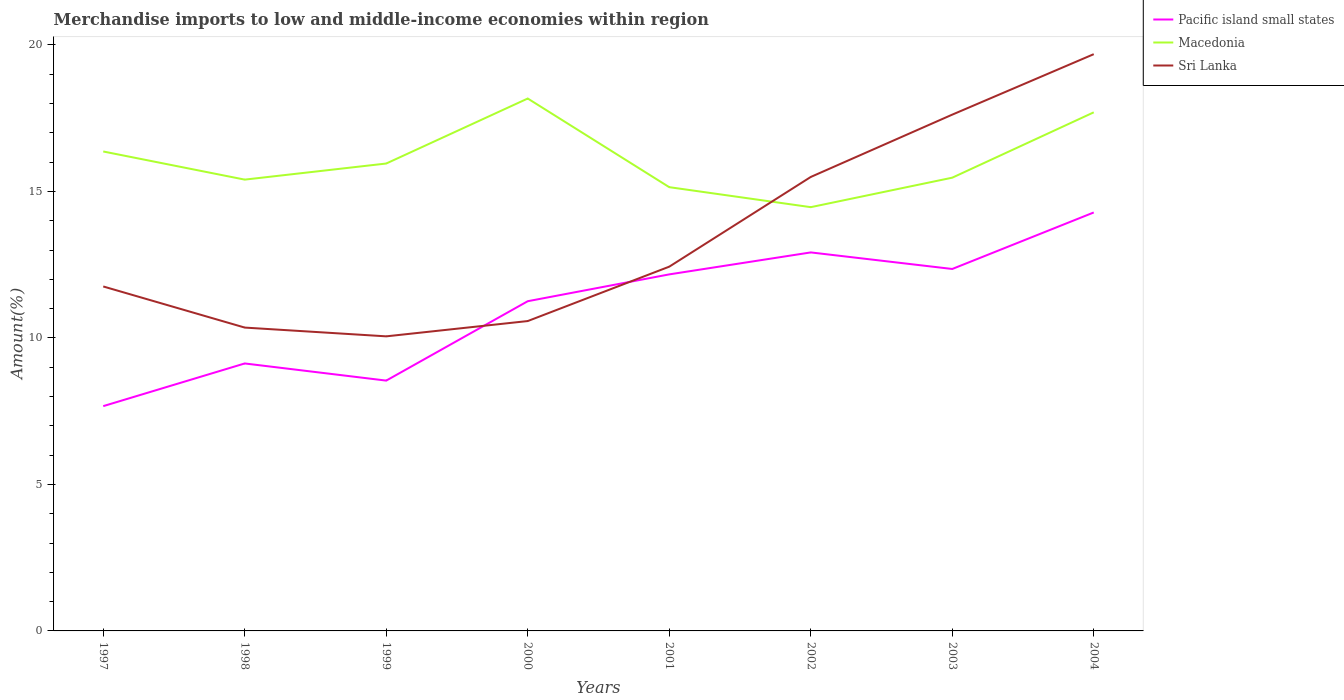How many different coloured lines are there?
Offer a terse response. 3. Does the line corresponding to Sri Lanka intersect with the line corresponding to Macedonia?
Ensure brevity in your answer.  Yes. Is the number of lines equal to the number of legend labels?
Ensure brevity in your answer.  Yes. Across all years, what is the maximum percentage of amount earned from merchandise imports in Sri Lanka?
Offer a terse response. 10.05. In which year was the percentage of amount earned from merchandise imports in Macedonia maximum?
Offer a very short reply. 2002. What is the total percentage of amount earned from merchandise imports in Sri Lanka in the graph?
Ensure brevity in your answer.  -0.22. What is the difference between the highest and the second highest percentage of amount earned from merchandise imports in Macedonia?
Your response must be concise. 3.71. Is the percentage of amount earned from merchandise imports in Pacific island small states strictly greater than the percentage of amount earned from merchandise imports in Macedonia over the years?
Provide a succinct answer. Yes. Are the values on the major ticks of Y-axis written in scientific E-notation?
Make the answer very short. No. Does the graph contain any zero values?
Make the answer very short. No. Where does the legend appear in the graph?
Your answer should be compact. Top right. How many legend labels are there?
Offer a very short reply. 3. What is the title of the graph?
Your answer should be compact. Merchandise imports to low and middle-income economies within region. Does "St. Martin (French part)" appear as one of the legend labels in the graph?
Give a very brief answer. No. What is the label or title of the Y-axis?
Your answer should be very brief. Amount(%). What is the Amount(%) of Pacific island small states in 1997?
Keep it short and to the point. 7.67. What is the Amount(%) of Macedonia in 1997?
Your answer should be compact. 16.36. What is the Amount(%) in Sri Lanka in 1997?
Your answer should be compact. 11.76. What is the Amount(%) of Pacific island small states in 1998?
Offer a very short reply. 9.13. What is the Amount(%) of Macedonia in 1998?
Offer a terse response. 15.4. What is the Amount(%) in Sri Lanka in 1998?
Your answer should be compact. 10.35. What is the Amount(%) of Pacific island small states in 1999?
Provide a succinct answer. 8.54. What is the Amount(%) in Macedonia in 1999?
Provide a short and direct response. 15.95. What is the Amount(%) in Sri Lanka in 1999?
Offer a terse response. 10.05. What is the Amount(%) in Pacific island small states in 2000?
Offer a terse response. 11.25. What is the Amount(%) of Macedonia in 2000?
Your answer should be compact. 18.17. What is the Amount(%) of Sri Lanka in 2000?
Provide a succinct answer. 10.58. What is the Amount(%) in Pacific island small states in 2001?
Give a very brief answer. 12.17. What is the Amount(%) in Macedonia in 2001?
Your response must be concise. 15.15. What is the Amount(%) in Sri Lanka in 2001?
Provide a succinct answer. 12.43. What is the Amount(%) in Pacific island small states in 2002?
Give a very brief answer. 12.92. What is the Amount(%) of Macedonia in 2002?
Keep it short and to the point. 14.46. What is the Amount(%) of Sri Lanka in 2002?
Provide a succinct answer. 15.49. What is the Amount(%) in Pacific island small states in 2003?
Your answer should be very brief. 12.35. What is the Amount(%) in Macedonia in 2003?
Make the answer very short. 15.47. What is the Amount(%) of Sri Lanka in 2003?
Ensure brevity in your answer.  17.62. What is the Amount(%) in Pacific island small states in 2004?
Keep it short and to the point. 14.28. What is the Amount(%) of Macedonia in 2004?
Offer a very short reply. 17.7. What is the Amount(%) in Sri Lanka in 2004?
Your answer should be very brief. 19.69. Across all years, what is the maximum Amount(%) of Pacific island small states?
Your answer should be very brief. 14.28. Across all years, what is the maximum Amount(%) of Macedonia?
Offer a very short reply. 18.17. Across all years, what is the maximum Amount(%) in Sri Lanka?
Your answer should be compact. 19.69. Across all years, what is the minimum Amount(%) in Pacific island small states?
Offer a very short reply. 7.67. Across all years, what is the minimum Amount(%) in Macedonia?
Your answer should be compact. 14.46. Across all years, what is the minimum Amount(%) of Sri Lanka?
Keep it short and to the point. 10.05. What is the total Amount(%) in Pacific island small states in the graph?
Ensure brevity in your answer.  88.32. What is the total Amount(%) in Macedonia in the graph?
Make the answer very short. 128.67. What is the total Amount(%) in Sri Lanka in the graph?
Provide a short and direct response. 107.98. What is the difference between the Amount(%) of Pacific island small states in 1997 and that in 1998?
Your response must be concise. -1.46. What is the difference between the Amount(%) in Macedonia in 1997 and that in 1998?
Provide a short and direct response. 0.96. What is the difference between the Amount(%) of Sri Lanka in 1997 and that in 1998?
Keep it short and to the point. 1.4. What is the difference between the Amount(%) in Pacific island small states in 1997 and that in 1999?
Ensure brevity in your answer.  -0.87. What is the difference between the Amount(%) of Macedonia in 1997 and that in 1999?
Keep it short and to the point. 0.41. What is the difference between the Amount(%) in Sri Lanka in 1997 and that in 1999?
Your answer should be compact. 1.7. What is the difference between the Amount(%) of Pacific island small states in 1997 and that in 2000?
Give a very brief answer. -3.58. What is the difference between the Amount(%) of Macedonia in 1997 and that in 2000?
Provide a short and direct response. -1.81. What is the difference between the Amount(%) of Sri Lanka in 1997 and that in 2000?
Provide a short and direct response. 1.18. What is the difference between the Amount(%) in Pacific island small states in 1997 and that in 2001?
Your answer should be compact. -4.5. What is the difference between the Amount(%) of Macedonia in 1997 and that in 2001?
Your response must be concise. 1.22. What is the difference between the Amount(%) in Sri Lanka in 1997 and that in 2001?
Offer a terse response. -0.68. What is the difference between the Amount(%) in Pacific island small states in 1997 and that in 2002?
Your response must be concise. -5.25. What is the difference between the Amount(%) of Macedonia in 1997 and that in 2002?
Your answer should be compact. 1.9. What is the difference between the Amount(%) in Sri Lanka in 1997 and that in 2002?
Your answer should be compact. -3.74. What is the difference between the Amount(%) of Pacific island small states in 1997 and that in 2003?
Keep it short and to the point. -4.68. What is the difference between the Amount(%) of Macedonia in 1997 and that in 2003?
Offer a very short reply. 0.89. What is the difference between the Amount(%) of Sri Lanka in 1997 and that in 2003?
Your response must be concise. -5.86. What is the difference between the Amount(%) in Pacific island small states in 1997 and that in 2004?
Give a very brief answer. -6.61. What is the difference between the Amount(%) in Macedonia in 1997 and that in 2004?
Keep it short and to the point. -1.34. What is the difference between the Amount(%) in Sri Lanka in 1997 and that in 2004?
Keep it short and to the point. -7.93. What is the difference between the Amount(%) of Pacific island small states in 1998 and that in 1999?
Provide a succinct answer. 0.59. What is the difference between the Amount(%) in Macedonia in 1998 and that in 1999?
Keep it short and to the point. -0.55. What is the difference between the Amount(%) of Sri Lanka in 1998 and that in 1999?
Provide a succinct answer. 0.3. What is the difference between the Amount(%) in Pacific island small states in 1998 and that in 2000?
Your response must be concise. -2.12. What is the difference between the Amount(%) of Macedonia in 1998 and that in 2000?
Keep it short and to the point. -2.77. What is the difference between the Amount(%) of Sri Lanka in 1998 and that in 2000?
Provide a succinct answer. -0.22. What is the difference between the Amount(%) in Pacific island small states in 1998 and that in 2001?
Provide a succinct answer. -3.04. What is the difference between the Amount(%) of Macedonia in 1998 and that in 2001?
Offer a terse response. 0.26. What is the difference between the Amount(%) in Sri Lanka in 1998 and that in 2001?
Your answer should be very brief. -2.08. What is the difference between the Amount(%) of Pacific island small states in 1998 and that in 2002?
Make the answer very short. -3.79. What is the difference between the Amount(%) in Macedonia in 1998 and that in 2002?
Make the answer very short. 0.94. What is the difference between the Amount(%) in Sri Lanka in 1998 and that in 2002?
Your response must be concise. -5.14. What is the difference between the Amount(%) in Pacific island small states in 1998 and that in 2003?
Give a very brief answer. -3.23. What is the difference between the Amount(%) in Macedonia in 1998 and that in 2003?
Make the answer very short. -0.07. What is the difference between the Amount(%) in Sri Lanka in 1998 and that in 2003?
Offer a terse response. -7.27. What is the difference between the Amount(%) in Pacific island small states in 1998 and that in 2004?
Make the answer very short. -5.15. What is the difference between the Amount(%) of Macedonia in 1998 and that in 2004?
Ensure brevity in your answer.  -2.3. What is the difference between the Amount(%) of Sri Lanka in 1998 and that in 2004?
Ensure brevity in your answer.  -9.33. What is the difference between the Amount(%) of Pacific island small states in 1999 and that in 2000?
Your answer should be compact. -2.71. What is the difference between the Amount(%) in Macedonia in 1999 and that in 2000?
Provide a succinct answer. -2.22. What is the difference between the Amount(%) in Sri Lanka in 1999 and that in 2000?
Your response must be concise. -0.52. What is the difference between the Amount(%) in Pacific island small states in 1999 and that in 2001?
Your answer should be compact. -3.63. What is the difference between the Amount(%) of Macedonia in 1999 and that in 2001?
Ensure brevity in your answer.  0.81. What is the difference between the Amount(%) of Sri Lanka in 1999 and that in 2001?
Keep it short and to the point. -2.38. What is the difference between the Amount(%) of Pacific island small states in 1999 and that in 2002?
Your response must be concise. -4.38. What is the difference between the Amount(%) in Macedonia in 1999 and that in 2002?
Your response must be concise. 1.49. What is the difference between the Amount(%) in Sri Lanka in 1999 and that in 2002?
Ensure brevity in your answer.  -5.44. What is the difference between the Amount(%) of Pacific island small states in 1999 and that in 2003?
Your answer should be very brief. -3.81. What is the difference between the Amount(%) in Macedonia in 1999 and that in 2003?
Ensure brevity in your answer.  0.48. What is the difference between the Amount(%) in Sri Lanka in 1999 and that in 2003?
Your answer should be compact. -7.57. What is the difference between the Amount(%) of Pacific island small states in 1999 and that in 2004?
Give a very brief answer. -5.74. What is the difference between the Amount(%) in Macedonia in 1999 and that in 2004?
Make the answer very short. -1.75. What is the difference between the Amount(%) in Sri Lanka in 1999 and that in 2004?
Keep it short and to the point. -9.63. What is the difference between the Amount(%) of Pacific island small states in 2000 and that in 2001?
Your response must be concise. -0.92. What is the difference between the Amount(%) in Macedonia in 2000 and that in 2001?
Offer a terse response. 3.03. What is the difference between the Amount(%) of Sri Lanka in 2000 and that in 2001?
Offer a very short reply. -1.86. What is the difference between the Amount(%) of Pacific island small states in 2000 and that in 2002?
Offer a very short reply. -1.67. What is the difference between the Amount(%) of Macedonia in 2000 and that in 2002?
Offer a terse response. 3.71. What is the difference between the Amount(%) of Sri Lanka in 2000 and that in 2002?
Give a very brief answer. -4.92. What is the difference between the Amount(%) of Pacific island small states in 2000 and that in 2003?
Offer a terse response. -1.1. What is the difference between the Amount(%) of Macedonia in 2000 and that in 2003?
Your answer should be compact. 2.7. What is the difference between the Amount(%) in Sri Lanka in 2000 and that in 2003?
Give a very brief answer. -7.05. What is the difference between the Amount(%) in Pacific island small states in 2000 and that in 2004?
Your response must be concise. -3.03. What is the difference between the Amount(%) of Macedonia in 2000 and that in 2004?
Your answer should be compact. 0.47. What is the difference between the Amount(%) in Sri Lanka in 2000 and that in 2004?
Keep it short and to the point. -9.11. What is the difference between the Amount(%) in Pacific island small states in 2001 and that in 2002?
Provide a short and direct response. -0.75. What is the difference between the Amount(%) of Macedonia in 2001 and that in 2002?
Offer a very short reply. 0.68. What is the difference between the Amount(%) of Sri Lanka in 2001 and that in 2002?
Your answer should be compact. -3.06. What is the difference between the Amount(%) in Pacific island small states in 2001 and that in 2003?
Give a very brief answer. -0.18. What is the difference between the Amount(%) of Macedonia in 2001 and that in 2003?
Keep it short and to the point. -0.32. What is the difference between the Amount(%) of Sri Lanka in 2001 and that in 2003?
Your response must be concise. -5.19. What is the difference between the Amount(%) in Pacific island small states in 2001 and that in 2004?
Your answer should be compact. -2.11. What is the difference between the Amount(%) in Macedonia in 2001 and that in 2004?
Your response must be concise. -2.55. What is the difference between the Amount(%) of Sri Lanka in 2001 and that in 2004?
Your response must be concise. -7.25. What is the difference between the Amount(%) of Pacific island small states in 2002 and that in 2003?
Your answer should be compact. 0.56. What is the difference between the Amount(%) in Macedonia in 2002 and that in 2003?
Your response must be concise. -1.01. What is the difference between the Amount(%) in Sri Lanka in 2002 and that in 2003?
Keep it short and to the point. -2.13. What is the difference between the Amount(%) in Pacific island small states in 2002 and that in 2004?
Provide a short and direct response. -1.36. What is the difference between the Amount(%) in Macedonia in 2002 and that in 2004?
Offer a terse response. -3.24. What is the difference between the Amount(%) of Sri Lanka in 2002 and that in 2004?
Provide a succinct answer. -4.19. What is the difference between the Amount(%) in Pacific island small states in 2003 and that in 2004?
Ensure brevity in your answer.  -1.93. What is the difference between the Amount(%) of Macedonia in 2003 and that in 2004?
Offer a terse response. -2.23. What is the difference between the Amount(%) in Sri Lanka in 2003 and that in 2004?
Your answer should be compact. -2.06. What is the difference between the Amount(%) of Pacific island small states in 1997 and the Amount(%) of Macedonia in 1998?
Offer a very short reply. -7.73. What is the difference between the Amount(%) in Pacific island small states in 1997 and the Amount(%) in Sri Lanka in 1998?
Offer a terse response. -2.68. What is the difference between the Amount(%) in Macedonia in 1997 and the Amount(%) in Sri Lanka in 1998?
Provide a succinct answer. 6.01. What is the difference between the Amount(%) of Pacific island small states in 1997 and the Amount(%) of Macedonia in 1999?
Give a very brief answer. -8.28. What is the difference between the Amount(%) of Pacific island small states in 1997 and the Amount(%) of Sri Lanka in 1999?
Provide a short and direct response. -2.38. What is the difference between the Amount(%) in Macedonia in 1997 and the Amount(%) in Sri Lanka in 1999?
Keep it short and to the point. 6.31. What is the difference between the Amount(%) in Pacific island small states in 1997 and the Amount(%) in Macedonia in 2000?
Offer a terse response. -10.5. What is the difference between the Amount(%) of Pacific island small states in 1997 and the Amount(%) of Sri Lanka in 2000?
Ensure brevity in your answer.  -2.9. What is the difference between the Amount(%) of Macedonia in 1997 and the Amount(%) of Sri Lanka in 2000?
Give a very brief answer. 5.79. What is the difference between the Amount(%) of Pacific island small states in 1997 and the Amount(%) of Macedonia in 2001?
Ensure brevity in your answer.  -7.47. What is the difference between the Amount(%) in Pacific island small states in 1997 and the Amount(%) in Sri Lanka in 2001?
Ensure brevity in your answer.  -4.76. What is the difference between the Amount(%) in Macedonia in 1997 and the Amount(%) in Sri Lanka in 2001?
Provide a succinct answer. 3.93. What is the difference between the Amount(%) of Pacific island small states in 1997 and the Amount(%) of Macedonia in 2002?
Your answer should be compact. -6.79. What is the difference between the Amount(%) of Pacific island small states in 1997 and the Amount(%) of Sri Lanka in 2002?
Your answer should be compact. -7.82. What is the difference between the Amount(%) in Macedonia in 1997 and the Amount(%) in Sri Lanka in 2002?
Your response must be concise. 0.87. What is the difference between the Amount(%) in Pacific island small states in 1997 and the Amount(%) in Macedonia in 2003?
Your answer should be very brief. -7.8. What is the difference between the Amount(%) of Pacific island small states in 1997 and the Amount(%) of Sri Lanka in 2003?
Offer a terse response. -9.95. What is the difference between the Amount(%) in Macedonia in 1997 and the Amount(%) in Sri Lanka in 2003?
Ensure brevity in your answer.  -1.26. What is the difference between the Amount(%) of Pacific island small states in 1997 and the Amount(%) of Macedonia in 2004?
Your response must be concise. -10.03. What is the difference between the Amount(%) of Pacific island small states in 1997 and the Amount(%) of Sri Lanka in 2004?
Provide a succinct answer. -12.01. What is the difference between the Amount(%) of Macedonia in 1997 and the Amount(%) of Sri Lanka in 2004?
Offer a terse response. -3.32. What is the difference between the Amount(%) of Pacific island small states in 1998 and the Amount(%) of Macedonia in 1999?
Offer a terse response. -6.82. What is the difference between the Amount(%) of Pacific island small states in 1998 and the Amount(%) of Sri Lanka in 1999?
Provide a short and direct response. -0.93. What is the difference between the Amount(%) of Macedonia in 1998 and the Amount(%) of Sri Lanka in 1999?
Your answer should be very brief. 5.35. What is the difference between the Amount(%) of Pacific island small states in 1998 and the Amount(%) of Macedonia in 2000?
Your response must be concise. -9.04. What is the difference between the Amount(%) of Pacific island small states in 1998 and the Amount(%) of Sri Lanka in 2000?
Keep it short and to the point. -1.45. What is the difference between the Amount(%) of Macedonia in 1998 and the Amount(%) of Sri Lanka in 2000?
Your response must be concise. 4.83. What is the difference between the Amount(%) in Pacific island small states in 1998 and the Amount(%) in Macedonia in 2001?
Offer a very short reply. -6.02. What is the difference between the Amount(%) in Pacific island small states in 1998 and the Amount(%) in Sri Lanka in 2001?
Your answer should be compact. -3.3. What is the difference between the Amount(%) in Macedonia in 1998 and the Amount(%) in Sri Lanka in 2001?
Provide a short and direct response. 2.97. What is the difference between the Amount(%) in Pacific island small states in 1998 and the Amount(%) in Macedonia in 2002?
Keep it short and to the point. -5.33. What is the difference between the Amount(%) of Pacific island small states in 1998 and the Amount(%) of Sri Lanka in 2002?
Provide a succinct answer. -6.37. What is the difference between the Amount(%) of Macedonia in 1998 and the Amount(%) of Sri Lanka in 2002?
Give a very brief answer. -0.09. What is the difference between the Amount(%) in Pacific island small states in 1998 and the Amount(%) in Macedonia in 2003?
Keep it short and to the point. -6.34. What is the difference between the Amount(%) of Pacific island small states in 1998 and the Amount(%) of Sri Lanka in 2003?
Give a very brief answer. -8.49. What is the difference between the Amount(%) of Macedonia in 1998 and the Amount(%) of Sri Lanka in 2003?
Your answer should be very brief. -2.22. What is the difference between the Amount(%) in Pacific island small states in 1998 and the Amount(%) in Macedonia in 2004?
Offer a terse response. -8.57. What is the difference between the Amount(%) in Pacific island small states in 1998 and the Amount(%) in Sri Lanka in 2004?
Ensure brevity in your answer.  -10.56. What is the difference between the Amount(%) of Macedonia in 1998 and the Amount(%) of Sri Lanka in 2004?
Your answer should be compact. -4.28. What is the difference between the Amount(%) of Pacific island small states in 1999 and the Amount(%) of Macedonia in 2000?
Your response must be concise. -9.63. What is the difference between the Amount(%) of Pacific island small states in 1999 and the Amount(%) of Sri Lanka in 2000?
Give a very brief answer. -2.03. What is the difference between the Amount(%) in Macedonia in 1999 and the Amount(%) in Sri Lanka in 2000?
Give a very brief answer. 5.38. What is the difference between the Amount(%) in Pacific island small states in 1999 and the Amount(%) in Macedonia in 2001?
Keep it short and to the point. -6.6. What is the difference between the Amount(%) of Pacific island small states in 1999 and the Amount(%) of Sri Lanka in 2001?
Your response must be concise. -3.89. What is the difference between the Amount(%) of Macedonia in 1999 and the Amount(%) of Sri Lanka in 2001?
Your answer should be compact. 3.52. What is the difference between the Amount(%) in Pacific island small states in 1999 and the Amount(%) in Macedonia in 2002?
Offer a terse response. -5.92. What is the difference between the Amount(%) in Pacific island small states in 1999 and the Amount(%) in Sri Lanka in 2002?
Give a very brief answer. -6.95. What is the difference between the Amount(%) in Macedonia in 1999 and the Amount(%) in Sri Lanka in 2002?
Give a very brief answer. 0.46. What is the difference between the Amount(%) of Pacific island small states in 1999 and the Amount(%) of Macedonia in 2003?
Give a very brief answer. -6.93. What is the difference between the Amount(%) of Pacific island small states in 1999 and the Amount(%) of Sri Lanka in 2003?
Offer a very short reply. -9.08. What is the difference between the Amount(%) in Macedonia in 1999 and the Amount(%) in Sri Lanka in 2003?
Your response must be concise. -1.67. What is the difference between the Amount(%) in Pacific island small states in 1999 and the Amount(%) in Macedonia in 2004?
Offer a very short reply. -9.16. What is the difference between the Amount(%) of Pacific island small states in 1999 and the Amount(%) of Sri Lanka in 2004?
Make the answer very short. -11.14. What is the difference between the Amount(%) in Macedonia in 1999 and the Amount(%) in Sri Lanka in 2004?
Keep it short and to the point. -3.73. What is the difference between the Amount(%) in Pacific island small states in 2000 and the Amount(%) in Macedonia in 2001?
Offer a terse response. -3.89. What is the difference between the Amount(%) in Pacific island small states in 2000 and the Amount(%) in Sri Lanka in 2001?
Ensure brevity in your answer.  -1.18. What is the difference between the Amount(%) of Macedonia in 2000 and the Amount(%) of Sri Lanka in 2001?
Keep it short and to the point. 5.74. What is the difference between the Amount(%) in Pacific island small states in 2000 and the Amount(%) in Macedonia in 2002?
Your answer should be very brief. -3.21. What is the difference between the Amount(%) of Pacific island small states in 2000 and the Amount(%) of Sri Lanka in 2002?
Offer a very short reply. -4.24. What is the difference between the Amount(%) in Macedonia in 2000 and the Amount(%) in Sri Lanka in 2002?
Offer a very short reply. 2.68. What is the difference between the Amount(%) of Pacific island small states in 2000 and the Amount(%) of Macedonia in 2003?
Make the answer very short. -4.22. What is the difference between the Amount(%) of Pacific island small states in 2000 and the Amount(%) of Sri Lanka in 2003?
Your answer should be compact. -6.37. What is the difference between the Amount(%) of Macedonia in 2000 and the Amount(%) of Sri Lanka in 2003?
Provide a short and direct response. 0.55. What is the difference between the Amount(%) of Pacific island small states in 2000 and the Amount(%) of Macedonia in 2004?
Keep it short and to the point. -6.45. What is the difference between the Amount(%) in Pacific island small states in 2000 and the Amount(%) in Sri Lanka in 2004?
Make the answer very short. -8.43. What is the difference between the Amount(%) in Macedonia in 2000 and the Amount(%) in Sri Lanka in 2004?
Ensure brevity in your answer.  -1.51. What is the difference between the Amount(%) of Pacific island small states in 2001 and the Amount(%) of Macedonia in 2002?
Make the answer very short. -2.29. What is the difference between the Amount(%) in Pacific island small states in 2001 and the Amount(%) in Sri Lanka in 2002?
Ensure brevity in your answer.  -3.33. What is the difference between the Amount(%) of Macedonia in 2001 and the Amount(%) of Sri Lanka in 2002?
Your answer should be very brief. -0.35. What is the difference between the Amount(%) in Pacific island small states in 2001 and the Amount(%) in Macedonia in 2003?
Ensure brevity in your answer.  -3.3. What is the difference between the Amount(%) of Pacific island small states in 2001 and the Amount(%) of Sri Lanka in 2003?
Keep it short and to the point. -5.45. What is the difference between the Amount(%) in Macedonia in 2001 and the Amount(%) in Sri Lanka in 2003?
Offer a terse response. -2.48. What is the difference between the Amount(%) in Pacific island small states in 2001 and the Amount(%) in Macedonia in 2004?
Your response must be concise. -5.53. What is the difference between the Amount(%) in Pacific island small states in 2001 and the Amount(%) in Sri Lanka in 2004?
Offer a very short reply. -7.52. What is the difference between the Amount(%) of Macedonia in 2001 and the Amount(%) of Sri Lanka in 2004?
Provide a succinct answer. -4.54. What is the difference between the Amount(%) in Pacific island small states in 2002 and the Amount(%) in Macedonia in 2003?
Give a very brief answer. -2.55. What is the difference between the Amount(%) of Pacific island small states in 2002 and the Amount(%) of Sri Lanka in 2003?
Provide a succinct answer. -4.7. What is the difference between the Amount(%) in Macedonia in 2002 and the Amount(%) in Sri Lanka in 2003?
Provide a succinct answer. -3.16. What is the difference between the Amount(%) of Pacific island small states in 2002 and the Amount(%) of Macedonia in 2004?
Provide a short and direct response. -4.78. What is the difference between the Amount(%) in Pacific island small states in 2002 and the Amount(%) in Sri Lanka in 2004?
Ensure brevity in your answer.  -6.77. What is the difference between the Amount(%) of Macedonia in 2002 and the Amount(%) of Sri Lanka in 2004?
Your response must be concise. -5.22. What is the difference between the Amount(%) of Pacific island small states in 2003 and the Amount(%) of Macedonia in 2004?
Provide a succinct answer. -5.35. What is the difference between the Amount(%) in Pacific island small states in 2003 and the Amount(%) in Sri Lanka in 2004?
Your answer should be compact. -7.33. What is the difference between the Amount(%) in Macedonia in 2003 and the Amount(%) in Sri Lanka in 2004?
Your response must be concise. -4.22. What is the average Amount(%) in Pacific island small states per year?
Offer a terse response. 11.04. What is the average Amount(%) in Macedonia per year?
Make the answer very short. 16.08. What is the average Amount(%) of Sri Lanka per year?
Ensure brevity in your answer.  13.5. In the year 1997, what is the difference between the Amount(%) in Pacific island small states and Amount(%) in Macedonia?
Your answer should be very brief. -8.69. In the year 1997, what is the difference between the Amount(%) in Pacific island small states and Amount(%) in Sri Lanka?
Ensure brevity in your answer.  -4.08. In the year 1997, what is the difference between the Amount(%) of Macedonia and Amount(%) of Sri Lanka?
Your response must be concise. 4.61. In the year 1998, what is the difference between the Amount(%) in Pacific island small states and Amount(%) in Macedonia?
Keep it short and to the point. -6.27. In the year 1998, what is the difference between the Amount(%) in Pacific island small states and Amount(%) in Sri Lanka?
Provide a succinct answer. -1.22. In the year 1998, what is the difference between the Amount(%) in Macedonia and Amount(%) in Sri Lanka?
Keep it short and to the point. 5.05. In the year 1999, what is the difference between the Amount(%) in Pacific island small states and Amount(%) in Macedonia?
Provide a short and direct response. -7.41. In the year 1999, what is the difference between the Amount(%) in Pacific island small states and Amount(%) in Sri Lanka?
Offer a terse response. -1.51. In the year 1999, what is the difference between the Amount(%) in Macedonia and Amount(%) in Sri Lanka?
Your answer should be very brief. 5.9. In the year 2000, what is the difference between the Amount(%) of Pacific island small states and Amount(%) of Macedonia?
Your answer should be very brief. -6.92. In the year 2000, what is the difference between the Amount(%) of Pacific island small states and Amount(%) of Sri Lanka?
Your answer should be compact. 0.68. In the year 2000, what is the difference between the Amount(%) of Macedonia and Amount(%) of Sri Lanka?
Your response must be concise. 7.6. In the year 2001, what is the difference between the Amount(%) of Pacific island small states and Amount(%) of Macedonia?
Provide a short and direct response. -2.98. In the year 2001, what is the difference between the Amount(%) in Pacific island small states and Amount(%) in Sri Lanka?
Your answer should be very brief. -0.26. In the year 2001, what is the difference between the Amount(%) of Macedonia and Amount(%) of Sri Lanka?
Your response must be concise. 2.71. In the year 2002, what is the difference between the Amount(%) of Pacific island small states and Amount(%) of Macedonia?
Your answer should be very brief. -1.54. In the year 2002, what is the difference between the Amount(%) in Pacific island small states and Amount(%) in Sri Lanka?
Provide a succinct answer. -2.58. In the year 2002, what is the difference between the Amount(%) in Macedonia and Amount(%) in Sri Lanka?
Keep it short and to the point. -1.03. In the year 2003, what is the difference between the Amount(%) in Pacific island small states and Amount(%) in Macedonia?
Offer a terse response. -3.12. In the year 2003, what is the difference between the Amount(%) in Pacific island small states and Amount(%) in Sri Lanka?
Make the answer very short. -5.27. In the year 2003, what is the difference between the Amount(%) of Macedonia and Amount(%) of Sri Lanka?
Offer a very short reply. -2.15. In the year 2004, what is the difference between the Amount(%) of Pacific island small states and Amount(%) of Macedonia?
Your response must be concise. -3.42. In the year 2004, what is the difference between the Amount(%) of Pacific island small states and Amount(%) of Sri Lanka?
Offer a terse response. -5.4. In the year 2004, what is the difference between the Amount(%) in Macedonia and Amount(%) in Sri Lanka?
Provide a short and direct response. -1.99. What is the ratio of the Amount(%) in Pacific island small states in 1997 to that in 1998?
Your answer should be very brief. 0.84. What is the ratio of the Amount(%) of Macedonia in 1997 to that in 1998?
Your response must be concise. 1.06. What is the ratio of the Amount(%) of Sri Lanka in 1997 to that in 1998?
Your answer should be very brief. 1.14. What is the ratio of the Amount(%) in Pacific island small states in 1997 to that in 1999?
Your answer should be very brief. 0.9. What is the ratio of the Amount(%) in Macedonia in 1997 to that in 1999?
Give a very brief answer. 1.03. What is the ratio of the Amount(%) in Sri Lanka in 1997 to that in 1999?
Your answer should be compact. 1.17. What is the ratio of the Amount(%) of Pacific island small states in 1997 to that in 2000?
Offer a terse response. 0.68. What is the ratio of the Amount(%) in Macedonia in 1997 to that in 2000?
Keep it short and to the point. 0.9. What is the ratio of the Amount(%) of Sri Lanka in 1997 to that in 2000?
Ensure brevity in your answer.  1.11. What is the ratio of the Amount(%) in Pacific island small states in 1997 to that in 2001?
Your answer should be compact. 0.63. What is the ratio of the Amount(%) of Macedonia in 1997 to that in 2001?
Your response must be concise. 1.08. What is the ratio of the Amount(%) in Sri Lanka in 1997 to that in 2001?
Provide a succinct answer. 0.95. What is the ratio of the Amount(%) of Pacific island small states in 1997 to that in 2002?
Give a very brief answer. 0.59. What is the ratio of the Amount(%) in Macedonia in 1997 to that in 2002?
Ensure brevity in your answer.  1.13. What is the ratio of the Amount(%) in Sri Lanka in 1997 to that in 2002?
Give a very brief answer. 0.76. What is the ratio of the Amount(%) of Pacific island small states in 1997 to that in 2003?
Offer a terse response. 0.62. What is the ratio of the Amount(%) in Macedonia in 1997 to that in 2003?
Your answer should be compact. 1.06. What is the ratio of the Amount(%) in Sri Lanka in 1997 to that in 2003?
Your answer should be very brief. 0.67. What is the ratio of the Amount(%) in Pacific island small states in 1997 to that in 2004?
Offer a very short reply. 0.54. What is the ratio of the Amount(%) in Macedonia in 1997 to that in 2004?
Provide a succinct answer. 0.92. What is the ratio of the Amount(%) of Sri Lanka in 1997 to that in 2004?
Ensure brevity in your answer.  0.6. What is the ratio of the Amount(%) of Pacific island small states in 1998 to that in 1999?
Ensure brevity in your answer.  1.07. What is the ratio of the Amount(%) of Macedonia in 1998 to that in 1999?
Your answer should be very brief. 0.97. What is the ratio of the Amount(%) of Sri Lanka in 1998 to that in 1999?
Your response must be concise. 1.03. What is the ratio of the Amount(%) of Pacific island small states in 1998 to that in 2000?
Provide a succinct answer. 0.81. What is the ratio of the Amount(%) of Macedonia in 1998 to that in 2000?
Your answer should be very brief. 0.85. What is the ratio of the Amount(%) in Sri Lanka in 1998 to that in 2000?
Give a very brief answer. 0.98. What is the ratio of the Amount(%) in Pacific island small states in 1998 to that in 2001?
Give a very brief answer. 0.75. What is the ratio of the Amount(%) of Macedonia in 1998 to that in 2001?
Your answer should be very brief. 1.02. What is the ratio of the Amount(%) of Sri Lanka in 1998 to that in 2001?
Your answer should be compact. 0.83. What is the ratio of the Amount(%) in Pacific island small states in 1998 to that in 2002?
Provide a succinct answer. 0.71. What is the ratio of the Amount(%) in Macedonia in 1998 to that in 2002?
Provide a succinct answer. 1.06. What is the ratio of the Amount(%) in Sri Lanka in 1998 to that in 2002?
Ensure brevity in your answer.  0.67. What is the ratio of the Amount(%) in Pacific island small states in 1998 to that in 2003?
Offer a terse response. 0.74. What is the ratio of the Amount(%) of Macedonia in 1998 to that in 2003?
Your answer should be compact. 1. What is the ratio of the Amount(%) in Sri Lanka in 1998 to that in 2003?
Your answer should be very brief. 0.59. What is the ratio of the Amount(%) in Pacific island small states in 1998 to that in 2004?
Your answer should be very brief. 0.64. What is the ratio of the Amount(%) of Macedonia in 1998 to that in 2004?
Provide a short and direct response. 0.87. What is the ratio of the Amount(%) in Sri Lanka in 1998 to that in 2004?
Ensure brevity in your answer.  0.53. What is the ratio of the Amount(%) of Pacific island small states in 1999 to that in 2000?
Give a very brief answer. 0.76. What is the ratio of the Amount(%) in Macedonia in 1999 to that in 2000?
Your answer should be very brief. 0.88. What is the ratio of the Amount(%) in Sri Lanka in 1999 to that in 2000?
Provide a succinct answer. 0.95. What is the ratio of the Amount(%) in Pacific island small states in 1999 to that in 2001?
Offer a very short reply. 0.7. What is the ratio of the Amount(%) in Macedonia in 1999 to that in 2001?
Keep it short and to the point. 1.05. What is the ratio of the Amount(%) of Sri Lanka in 1999 to that in 2001?
Your answer should be compact. 0.81. What is the ratio of the Amount(%) in Pacific island small states in 1999 to that in 2002?
Your answer should be compact. 0.66. What is the ratio of the Amount(%) of Macedonia in 1999 to that in 2002?
Provide a succinct answer. 1.1. What is the ratio of the Amount(%) in Sri Lanka in 1999 to that in 2002?
Offer a very short reply. 0.65. What is the ratio of the Amount(%) of Pacific island small states in 1999 to that in 2003?
Make the answer very short. 0.69. What is the ratio of the Amount(%) of Macedonia in 1999 to that in 2003?
Ensure brevity in your answer.  1.03. What is the ratio of the Amount(%) in Sri Lanka in 1999 to that in 2003?
Offer a terse response. 0.57. What is the ratio of the Amount(%) in Pacific island small states in 1999 to that in 2004?
Provide a short and direct response. 0.6. What is the ratio of the Amount(%) in Macedonia in 1999 to that in 2004?
Make the answer very short. 0.9. What is the ratio of the Amount(%) of Sri Lanka in 1999 to that in 2004?
Give a very brief answer. 0.51. What is the ratio of the Amount(%) in Pacific island small states in 2000 to that in 2001?
Offer a very short reply. 0.92. What is the ratio of the Amount(%) of Macedonia in 2000 to that in 2001?
Your answer should be compact. 1.2. What is the ratio of the Amount(%) of Sri Lanka in 2000 to that in 2001?
Provide a short and direct response. 0.85. What is the ratio of the Amount(%) in Pacific island small states in 2000 to that in 2002?
Your response must be concise. 0.87. What is the ratio of the Amount(%) in Macedonia in 2000 to that in 2002?
Provide a short and direct response. 1.26. What is the ratio of the Amount(%) of Sri Lanka in 2000 to that in 2002?
Provide a succinct answer. 0.68. What is the ratio of the Amount(%) of Pacific island small states in 2000 to that in 2003?
Keep it short and to the point. 0.91. What is the ratio of the Amount(%) of Macedonia in 2000 to that in 2003?
Your answer should be compact. 1.17. What is the ratio of the Amount(%) of Sri Lanka in 2000 to that in 2003?
Ensure brevity in your answer.  0.6. What is the ratio of the Amount(%) in Pacific island small states in 2000 to that in 2004?
Ensure brevity in your answer.  0.79. What is the ratio of the Amount(%) in Macedonia in 2000 to that in 2004?
Provide a succinct answer. 1.03. What is the ratio of the Amount(%) of Sri Lanka in 2000 to that in 2004?
Ensure brevity in your answer.  0.54. What is the ratio of the Amount(%) of Pacific island small states in 2001 to that in 2002?
Make the answer very short. 0.94. What is the ratio of the Amount(%) of Macedonia in 2001 to that in 2002?
Make the answer very short. 1.05. What is the ratio of the Amount(%) in Sri Lanka in 2001 to that in 2002?
Provide a short and direct response. 0.8. What is the ratio of the Amount(%) in Pacific island small states in 2001 to that in 2003?
Keep it short and to the point. 0.99. What is the ratio of the Amount(%) of Macedonia in 2001 to that in 2003?
Offer a terse response. 0.98. What is the ratio of the Amount(%) in Sri Lanka in 2001 to that in 2003?
Give a very brief answer. 0.71. What is the ratio of the Amount(%) of Pacific island small states in 2001 to that in 2004?
Keep it short and to the point. 0.85. What is the ratio of the Amount(%) in Macedonia in 2001 to that in 2004?
Offer a very short reply. 0.86. What is the ratio of the Amount(%) of Sri Lanka in 2001 to that in 2004?
Your answer should be compact. 0.63. What is the ratio of the Amount(%) of Pacific island small states in 2002 to that in 2003?
Keep it short and to the point. 1.05. What is the ratio of the Amount(%) of Macedonia in 2002 to that in 2003?
Provide a short and direct response. 0.94. What is the ratio of the Amount(%) in Sri Lanka in 2002 to that in 2003?
Your response must be concise. 0.88. What is the ratio of the Amount(%) in Pacific island small states in 2002 to that in 2004?
Give a very brief answer. 0.9. What is the ratio of the Amount(%) of Macedonia in 2002 to that in 2004?
Offer a very short reply. 0.82. What is the ratio of the Amount(%) of Sri Lanka in 2002 to that in 2004?
Provide a succinct answer. 0.79. What is the ratio of the Amount(%) in Pacific island small states in 2003 to that in 2004?
Your response must be concise. 0.86. What is the ratio of the Amount(%) in Macedonia in 2003 to that in 2004?
Offer a very short reply. 0.87. What is the ratio of the Amount(%) of Sri Lanka in 2003 to that in 2004?
Keep it short and to the point. 0.9. What is the difference between the highest and the second highest Amount(%) in Pacific island small states?
Make the answer very short. 1.36. What is the difference between the highest and the second highest Amount(%) of Macedonia?
Your answer should be compact. 0.47. What is the difference between the highest and the second highest Amount(%) of Sri Lanka?
Offer a very short reply. 2.06. What is the difference between the highest and the lowest Amount(%) of Pacific island small states?
Your answer should be compact. 6.61. What is the difference between the highest and the lowest Amount(%) of Macedonia?
Your answer should be very brief. 3.71. What is the difference between the highest and the lowest Amount(%) in Sri Lanka?
Your answer should be very brief. 9.63. 